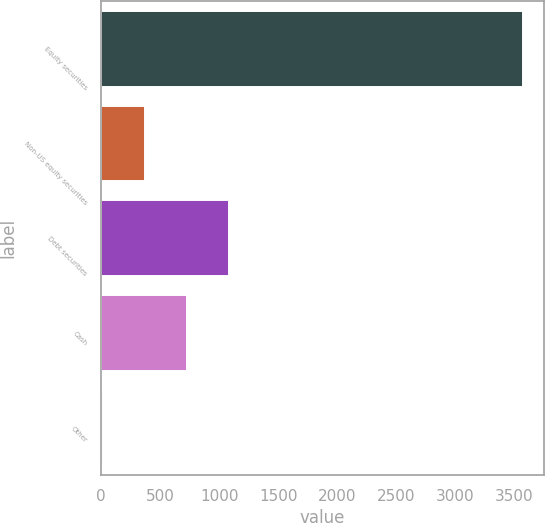<chart> <loc_0><loc_0><loc_500><loc_500><bar_chart><fcel>Equity securities<fcel>Non-US equity securities<fcel>Debt securities<fcel>Cash<fcel>Other<nl><fcel>3570<fcel>370.5<fcel>1081.5<fcel>726<fcel>15<nl></chart> 